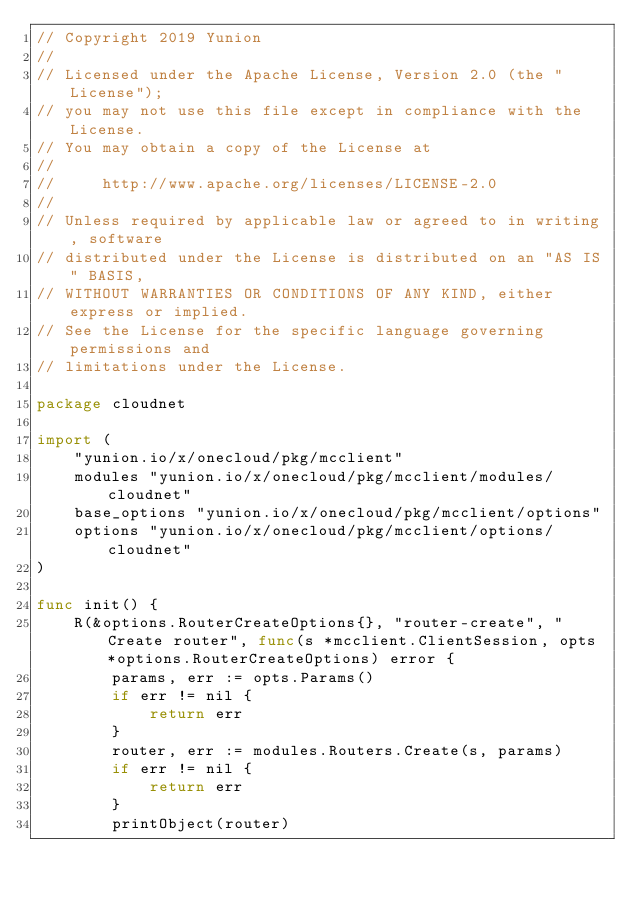Convert code to text. <code><loc_0><loc_0><loc_500><loc_500><_Go_>// Copyright 2019 Yunion
//
// Licensed under the Apache License, Version 2.0 (the "License");
// you may not use this file except in compliance with the License.
// You may obtain a copy of the License at
//
//     http://www.apache.org/licenses/LICENSE-2.0
//
// Unless required by applicable law or agreed to in writing, software
// distributed under the License is distributed on an "AS IS" BASIS,
// WITHOUT WARRANTIES OR CONDITIONS OF ANY KIND, either express or implied.
// See the License for the specific language governing permissions and
// limitations under the License.

package cloudnet

import (
	"yunion.io/x/onecloud/pkg/mcclient"
	modules "yunion.io/x/onecloud/pkg/mcclient/modules/cloudnet"
	base_options "yunion.io/x/onecloud/pkg/mcclient/options"
	options "yunion.io/x/onecloud/pkg/mcclient/options/cloudnet"
)

func init() {
	R(&options.RouterCreateOptions{}, "router-create", "Create router", func(s *mcclient.ClientSession, opts *options.RouterCreateOptions) error {
		params, err := opts.Params()
		if err != nil {
			return err
		}
		router, err := modules.Routers.Create(s, params)
		if err != nil {
			return err
		}
		printObject(router)</code> 